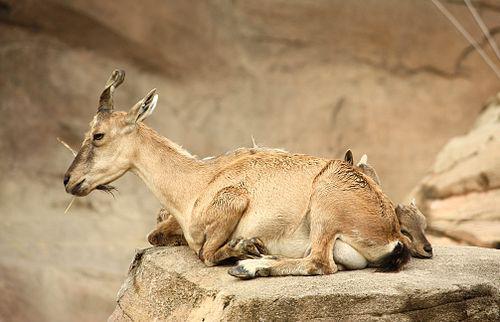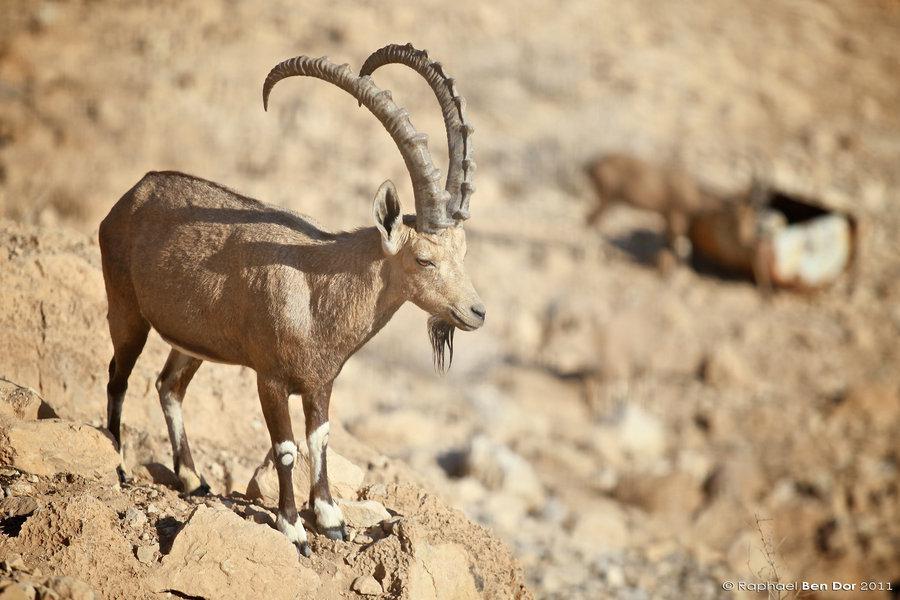The first image is the image on the left, the second image is the image on the right. Evaluate the accuracy of this statement regarding the images: "The left and right image contains a total of four goats.". Is it true? Answer yes or no. No. The first image is the image on the left, the second image is the image on the right. Evaluate the accuracy of this statement regarding the images: "The left image contains a bigger horned animal and at least one smaller animal without a set of prominent horns.". Is it true? Answer yes or no. Yes. 